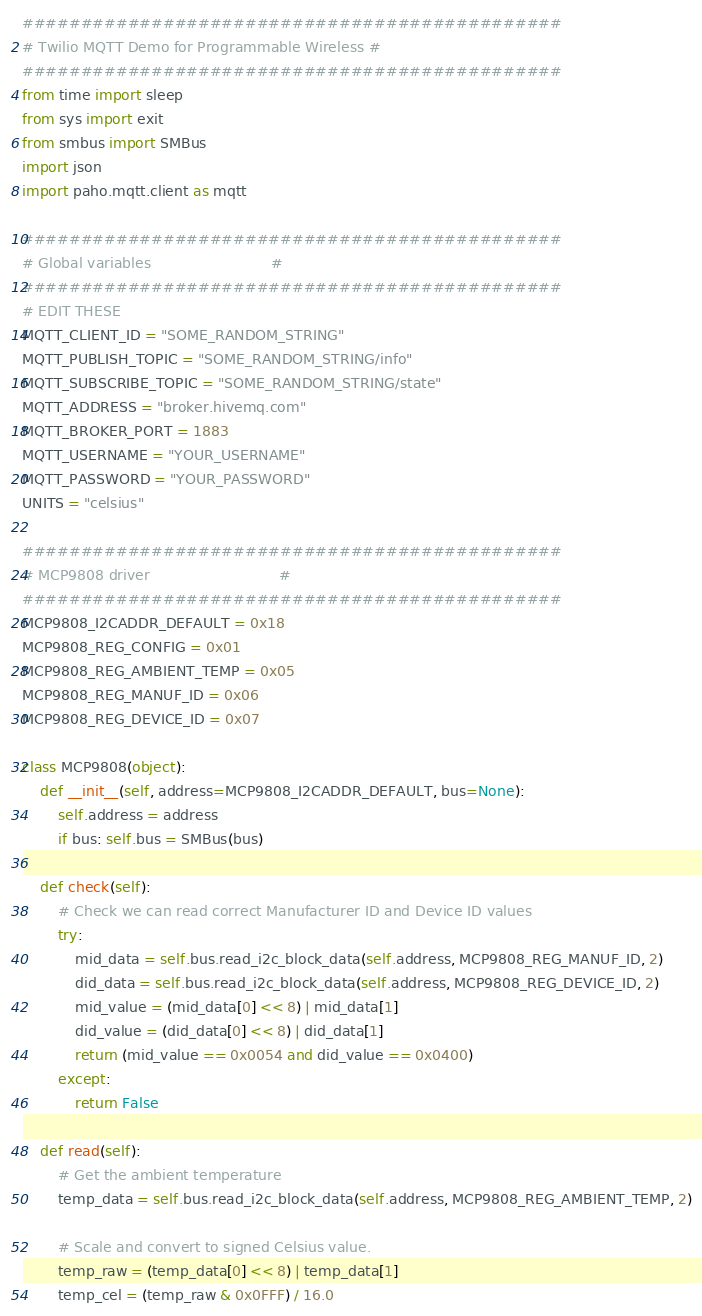<code> <loc_0><loc_0><loc_500><loc_500><_Python_>##############################################
# Twilio MQTT Demo for Programmable Wireless #
##############################################
from time import sleep
from sys import exit
from smbus import SMBus
import json
import paho.mqtt.client as mqtt

##############################################
# Global variables                           #
##############################################
# EDIT THESE
MQTT_CLIENT_ID = "SOME_RANDOM_STRING"
MQTT_PUBLISH_TOPIC = "SOME_RANDOM_STRING/info"
MQTT_SUBSCRIBE_TOPIC = "SOME_RANDOM_STRING/state"
MQTT_ADDRESS = "broker.hivemq.com"
MQTT_BROKER_PORT = 1883
MQTT_USERNAME = "YOUR_USERNAME"
MQTT_PASSWORD = "YOUR_PASSWORD"
UNITS = "celsius"

##############################################
# MCP9808 driver                             #
##############################################
MCP9808_I2CADDR_DEFAULT = 0x18
MCP9808_REG_CONFIG = 0x01
MCP9808_REG_AMBIENT_TEMP = 0x05
MCP9808_REG_MANUF_ID = 0x06
MCP9808_REG_DEVICE_ID = 0x07

class MCP9808(object):
    def __init__(self, address=MCP9808_I2CADDR_DEFAULT, bus=None):
        self.address = address
        if bus: self.bus = SMBus(bus)

    def check(self):
        # Check we can read correct Manufacturer ID and Device ID values
        try:
            mid_data = self.bus.read_i2c_block_data(self.address, MCP9808_REG_MANUF_ID, 2)
            did_data = self.bus.read_i2c_block_data(self.address, MCP9808_REG_DEVICE_ID, 2)
            mid_value = (mid_data[0] << 8) | mid_data[1]
            did_value = (did_data[0] << 8) | did_data[1]
            return (mid_value == 0x0054 and did_value == 0x0400)
        except:
            return False

    def read(self):
        # Get the ambient temperature
        temp_data = self.bus.read_i2c_block_data(self.address, MCP9808_REG_AMBIENT_TEMP, 2)

        # Scale and convert to signed Celsius value.
        temp_raw = (temp_data[0] << 8) | temp_data[1]
        temp_cel = (temp_raw & 0x0FFF) / 16.0</code> 